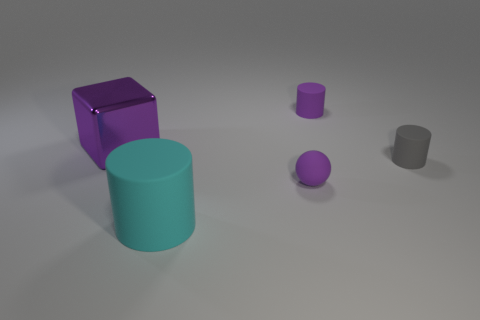Are there any other things that have the same material as the purple block?
Ensure brevity in your answer.  No. There is a cylinder to the left of the tiny purple rubber object that is behind the small gray rubber object; what is its color?
Your answer should be compact. Cyan. Are there any tiny things of the same color as the large shiny block?
Provide a succinct answer. Yes. There is a cylinder that is in front of the tiny purple object that is in front of the thing that is to the left of the cyan thing; what is its size?
Provide a succinct answer. Large. Do the large shiny thing and the small purple rubber object that is in front of the big purple metal cube have the same shape?
Give a very brief answer. No. How many other objects are the same size as the cyan rubber thing?
Your response must be concise. 1. There is a matte thing behind the block; what size is it?
Offer a terse response. Small. How many tiny cyan cylinders are the same material as the small purple sphere?
Provide a succinct answer. 0. There is a small purple matte thing that is in front of the purple shiny block; does it have the same shape as the purple metal thing?
Make the answer very short. No. What is the shape of the small purple matte thing that is behind the large purple metallic block?
Make the answer very short. Cylinder. 